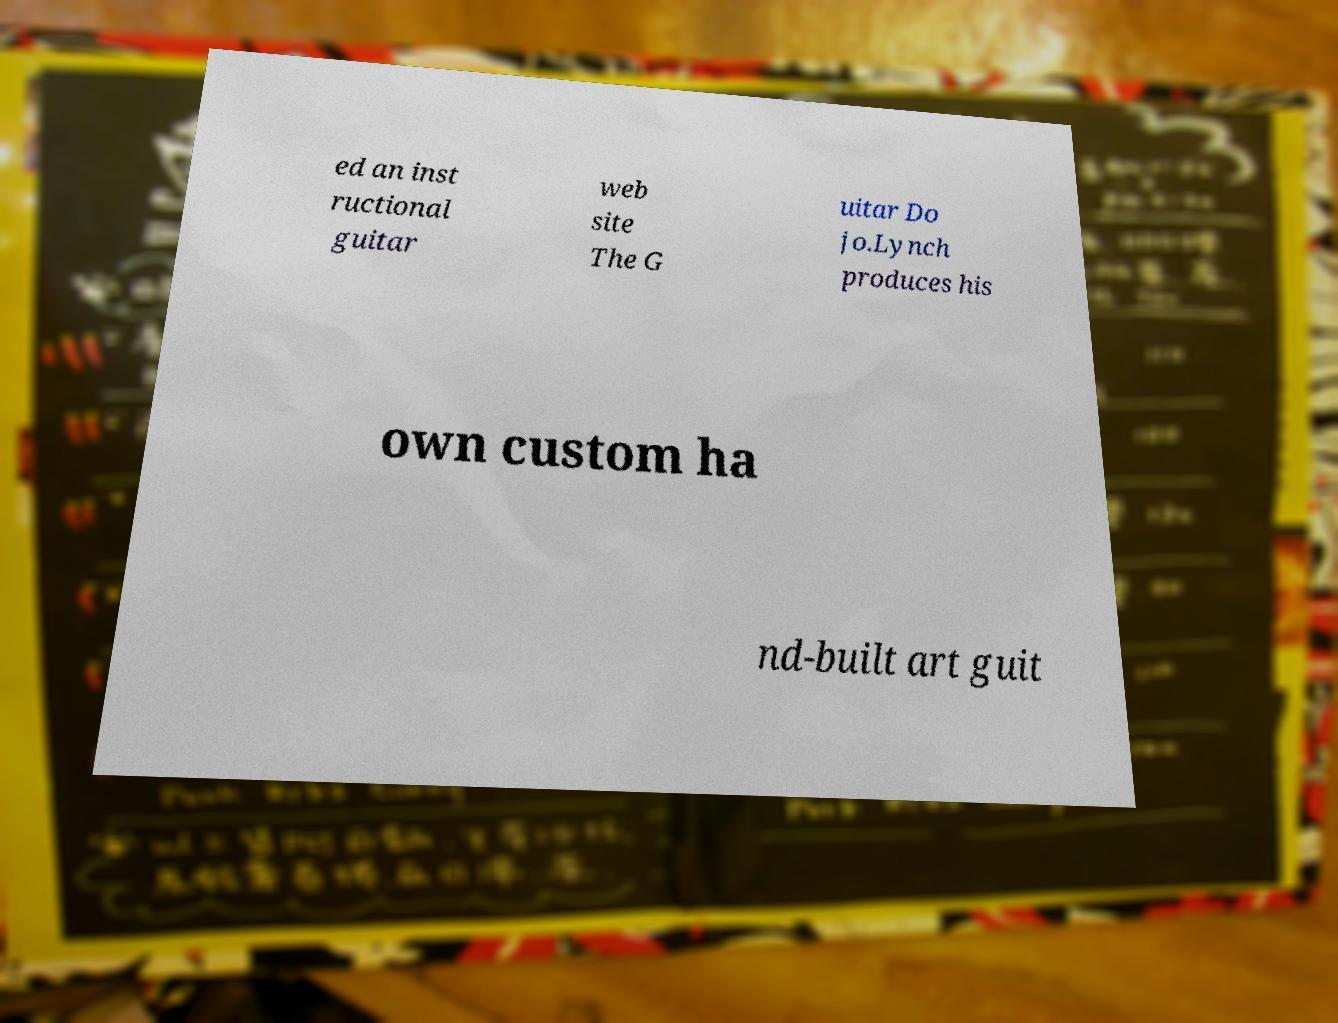Please identify and transcribe the text found in this image. ed an inst ructional guitar web site The G uitar Do jo.Lynch produces his own custom ha nd-built art guit 